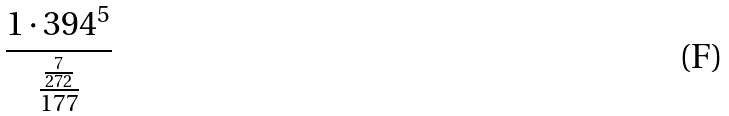Convert formula to latex. <formula><loc_0><loc_0><loc_500><loc_500>\frac { 1 \cdot 3 9 4 ^ { 5 } } { \frac { \frac { 7 } { 2 7 2 } } { 1 7 7 } }</formula> 